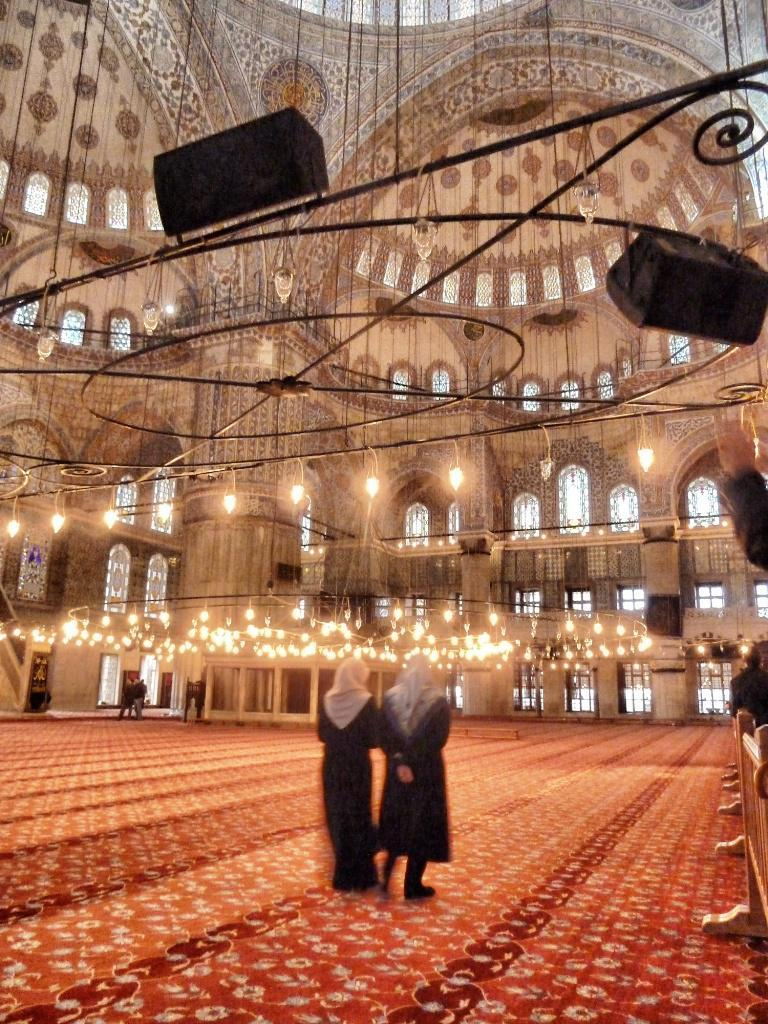How many people are in the image? There are two persons standing in the image. Where are the persons standing? The persons are standing on the floor. What type of lighting is present in the image? Ceiling lights are visible in the image. What objects can be seen in the image? There are objects in the image, but their specific nature is not mentioned in the facts. What type of seating is present in the image? Wooden benches are present in the image. What part of the room is visible in the image? The ceiling is visible in the image. What type of quartz is used as a decorative element in the image? There is no mention of quartz being used as a decorative element in the image. What appliance can be seen on the wooden benches in the image? There is no appliance visible on the wooden benches in the image. 